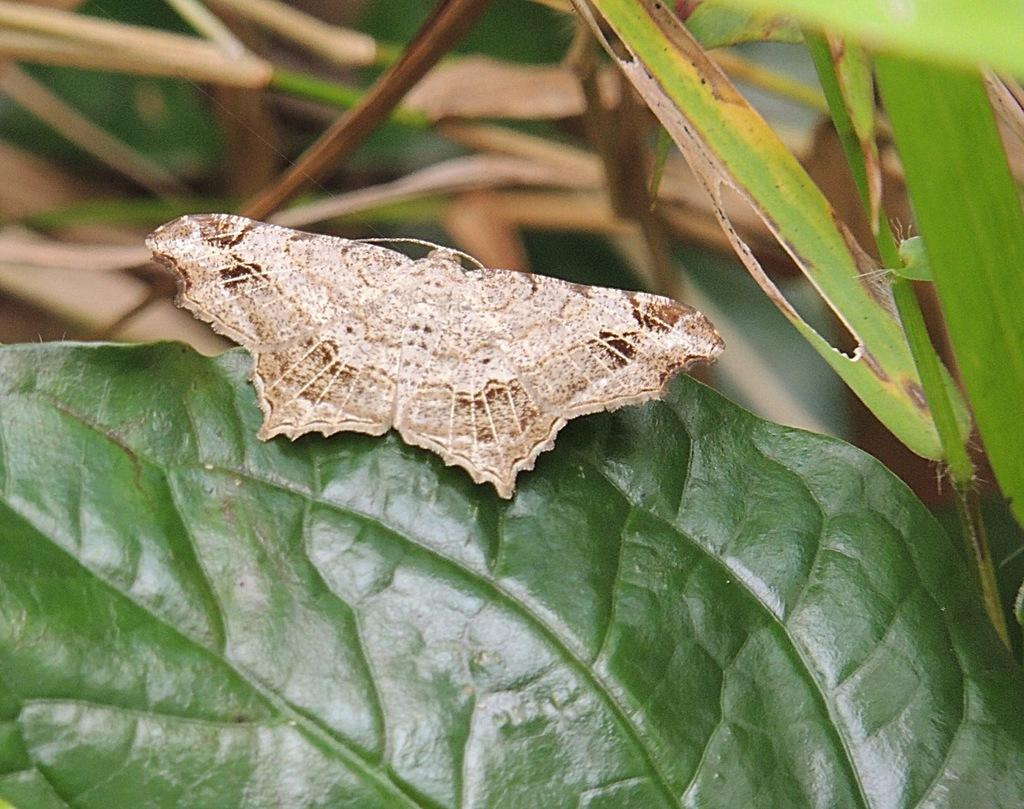What is the main subject of the image? There is a butterfly on a leaf in the image. What is located to the right of the butterfly? There are leaves to the right of the butterfly. How would you describe the background of the image? The background of the image is blurry. How many cows are visible in the image? There are no cows present in the image; it features a butterfly on a leaf with blurry background. 